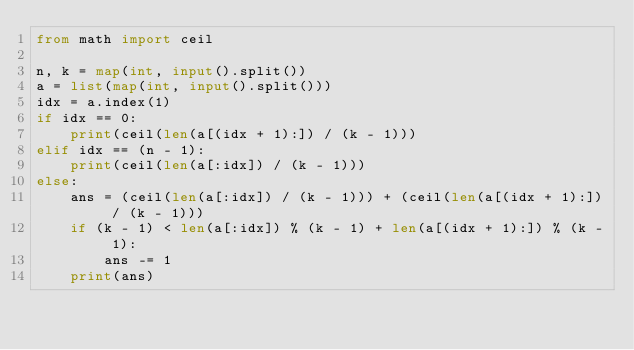<code> <loc_0><loc_0><loc_500><loc_500><_Python_>from math import ceil
 
n, k = map(int, input().split())
a = list(map(int, input().split()))
idx = a.index(1)
if idx == 0:
    print(ceil(len(a[(idx + 1):]) / (k - 1)))
elif idx == (n - 1):
    print(ceil(len(a[:idx]) / (k - 1)))
else:
    ans = (ceil(len(a[:idx]) / (k - 1))) + (ceil(len(a[(idx + 1):]) / (k - 1)))
    if (k - 1) < len(a[:idx]) % (k - 1) + len(a[(idx + 1):]) % (k - 1):
        ans -= 1
    print(ans)</code> 